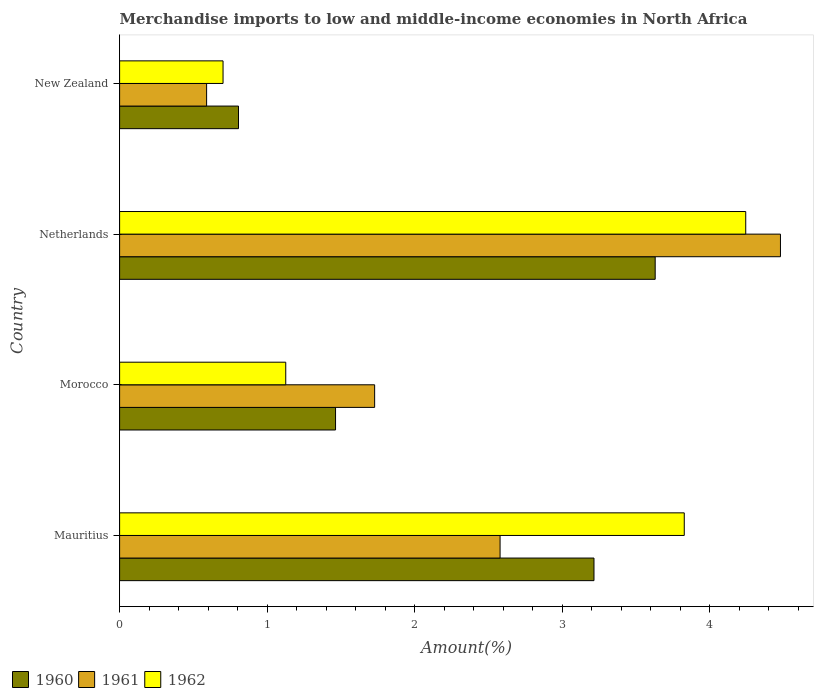How many different coloured bars are there?
Your answer should be compact. 3. How many groups of bars are there?
Ensure brevity in your answer.  4. Are the number of bars per tick equal to the number of legend labels?
Keep it short and to the point. Yes. What is the label of the 3rd group of bars from the top?
Ensure brevity in your answer.  Morocco. In how many cases, is the number of bars for a given country not equal to the number of legend labels?
Ensure brevity in your answer.  0. What is the percentage of amount earned from merchandise imports in 1960 in Netherlands?
Provide a short and direct response. 3.63. Across all countries, what is the maximum percentage of amount earned from merchandise imports in 1961?
Keep it short and to the point. 4.48. Across all countries, what is the minimum percentage of amount earned from merchandise imports in 1961?
Your response must be concise. 0.59. In which country was the percentage of amount earned from merchandise imports in 1961 maximum?
Your answer should be compact. Netherlands. In which country was the percentage of amount earned from merchandise imports in 1961 minimum?
Make the answer very short. New Zealand. What is the total percentage of amount earned from merchandise imports in 1962 in the graph?
Provide a short and direct response. 9.9. What is the difference between the percentage of amount earned from merchandise imports in 1960 in Mauritius and that in Netherlands?
Make the answer very short. -0.42. What is the difference between the percentage of amount earned from merchandise imports in 1961 in Netherlands and the percentage of amount earned from merchandise imports in 1960 in Mauritius?
Offer a very short reply. 1.26. What is the average percentage of amount earned from merchandise imports in 1961 per country?
Offer a terse response. 2.34. What is the difference between the percentage of amount earned from merchandise imports in 1962 and percentage of amount earned from merchandise imports in 1960 in Netherlands?
Give a very brief answer. 0.61. In how many countries, is the percentage of amount earned from merchandise imports in 1961 greater than 1 %?
Your response must be concise. 3. What is the ratio of the percentage of amount earned from merchandise imports in 1960 in Mauritius to that in Netherlands?
Offer a terse response. 0.89. What is the difference between the highest and the second highest percentage of amount earned from merchandise imports in 1962?
Provide a short and direct response. 0.42. What is the difference between the highest and the lowest percentage of amount earned from merchandise imports in 1961?
Make the answer very short. 3.89. What does the 1st bar from the bottom in New Zealand represents?
Offer a very short reply. 1960. Is it the case that in every country, the sum of the percentage of amount earned from merchandise imports in 1961 and percentage of amount earned from merchandise imports in 1960 is greater than the percentage of amount earned from merchandise imports in 1962?
Your response must be concise. Yes. Are all the bars in the graph horizontal?
Offer a terse response. Yes. What is the difference between two consecutive major ticks on the X-axis?
Make the answer very short. 1. Are the values on the major ticks of X-axis written in scientific E-notation?
Offer a terse response. No. Where does the legend appear in the graph?
Your response must be concise. Bottom left. What is the title of the graph?
Keep it short and to the point. Merchandise imports to low and middle-income economies in North Africa. Does "1989" appear as one of the legend labels in the graph?
Offer a terse response. No. What is the label or title of the X-axis?
Give a very brief answer. Amount(%). What is the label or title of the Y-axis?
Your answer should be very brief. Country. What is the Amount(%) in 1960 in Mauritius?
Provide a short and direct response. 3.22. What is the Amount(%) of 1961 in Mauritius?
Keep it short and to the point. 2.58. What is the Amount(%) of 1962 in Mauritius?
Your answer should be compact. 3.83. What is the Amount(%) of 1960 in Morocco?
Ensure brevity in your answer.  1.46. What is the Amount(%) of 1961 in Morocco?
Provide a succinct answer. 1.73. What is the Amount(%) of 1962 in Morocco?
Your answer should be compact. 1.13. What is the Amount(%) of 1960 in Netherlands?
Your answer should be compact. 3.63. What is the Amount(%) in 1961 in Netherlands?
Keep it short and to the point. 4.48. What is the Amount(%) of 1962 in Netherlands?
Your answer should be very brief. 4.25. What is the Amount(%) in 1960 in New Zealand?
Offer a terse response. 0.81. What is the Amount(%) in 1961 in New Zealand?
Offer a very short reply. 0.59. What is the Amount(%) in 1962 in New Zealand?
Your response must be concise. 0.7. Across all countries, what is the maximum Amount(%) of 1960?
Give a very brief answer. 3.63. Across all countries, what is the maximum Amount(%) of 1961?
Your answer should be compact. 4.48. Across all countries, what is the maximum Amount(%) of 1962?
Ensure brevity in your answer.  4.25. Across all countries, what is the minimum Amount(%) in 1960?
Keep it short and to the point. 0.81. Across all countries, what is the minimum Amount(%) in 1961?
Your response must be concise. 0.59. Across all countries, what is the minimum Amount(%) in 1962?
Keep it short and to the point. 0.7. What is the total Amount(%) in 1960 in the graph?
Offer a very short reply. 9.12. What is the total Amount(%) of 1961 in the graph?
Make the answer very short. 9.38. What is the total Amount(%) in 1962 in the graph?
Offer a very short reply. 9.9. What is the difference between the Amount(%) in 1960 in Mauritius and that in Morocco?
Give a very brief answer. 1.75. What is the difference between the Amount(%) in 1961 in Mauritius and that in Morocco?
Provide a succinct answer. 0.85. What is the difference between the Amount(%) of 1962 in Mauritius and that in Morocco?
Your answer should be compact. 2.7. What is the difference between the Amount(%) in 1960 in Mauritius and that in Netherlands?
Offer a very short reply. -0.41. What is the difference between the Amount(%) in 1961 in Mauritius and that in Netherlands?
Keep it short and to the point. -1.9. What is the difference between the Amount(%) of 1962 in Mauritius and that in Netherlands?
Give a very brief answer. -0.42. What is the difference between the Amount(%) of 1960 in Mauritius and that in New Zealand?
Your answer should be very brief. 2.41. What is the difference between the Amount(%) in 1961 in Mauritius and that in New Zealand?
Make the answer very short. 1.99. What is the difference between the Amount(%) of 1962 in Mauritius and that in New Zealand?
Offer a very short reply. 3.13. What is the difference between the Amount(%) in 1960 in Morocco and that in Netherlands?
Offer a very short reply. -2.17. What is the difference between the Amount(%) of 1961 in Morocco and that in Netherlands?
Offer a very short reply. -2.75. What is the difference between the Amount(%) in 1962 in Morocco and that in Netherlands?
Provide a short and direct response. -3.12. What is the difference between the Amount(%) in 1960 in Morocco and that in New Zealand?
Your response must be concise. 0.66. What is the difference between the Amount(%) of 1961 in Morocco and that in New Zealand?
Offer a very short reply. 1.14. What is the difference between the Amount(%) in 1962 in Morocco and that in New Zealand?
Provide a short and direct response. 0.43. What is the difference between the Amount(%) in 1960 in Netherlands and that in New Zealand?
Make the answer very short. 2.83. What is the difference between the Amount(%) of 1961 in Netherlands and that in New Zealand?
Make the answer very short. 3.89. What is the difference between the Amount(%) of 1962 in Netherlands and that in New Zealand?
Your answer should be compact. 3.54. What is the difference between the Amount(%) of 1960 in Mauritius and the Amount(%) of 1961 in Morocco?
Offer a very short reply. 1.49. What is the difference between the Amount(%) of 1960 in Mauritius and the Amount(%) of 1962 in Morocco?
Give a very brief answer. 2.09. What is the difference between the Amount(%) of 1961 in Mauritius and the Amount(%) of 1962 in Morocco?
Keep it short and to the point. 1.45. What is the difference between the Amount(%) in 1960 in Mauritius and the Amount(%) in 1961 in Netherlands?
Provide a short and direct response. -1.26. What is the difference between the Amount(%) of 1960 in Mauritius and the Amount(%) of 1962 in Netherlands?
Make the answer very short. -1.03. What is the difference between the Amount(%) of 1961 in Mauritius and the Amount(%) of 1962 in Netherlands?
Keep it short and to the point. -1.67. What is the difference between the Amount(%) of 1960 in Mauritius and the Amount(%) of 1961 in New Zealand?
Provide a short and direct response. 2.63. What is the difference between the Amount(%) in 1960 in Mauritius and the Amount(%) in 1962 in New Zealand?
Make the answer very short. 2.52. What is the difference between the Amount(%) in 1961 in Mauritius and the Amount(%) in 1962 in New Zealand?
Make the answer very short. 1.88. What is the difference between the Amount(%) of 1960 in Morocco and the Amount(%) of 1961 in Netherlands?
Keep it short and to the point. -3.02. What is the difference between the Amount(%) in 1960 in Morocco and the Amount(%) in 1962 in Netherlands?
Your answer should be compact. -2.78. What is the difference between the Amount(%) of 1961 in Morocco and the Amount(%) of 1962 in Netherlands?
Ensure brevity in your answer.  -2.52. What is the difference between the Amount(%) of 1960 in Morocco and the Amount(%) of 1961 in New Zealand?
Your answer should be very brief. 0.87. What is the difference between the Amount(%) in 1960 in Morocco and the Amount(%) in 1962 in New Zealand?
Offer a terse response. 0.76. What is the difference between the Amount(%) of 1961 in Morocco and the Amount(%) of 1962 in New Zealand?
Your answer should be very brief. 1.03. What is the difference between the Amount(%) in 1960 in Netherlands and the Amount(%) in 1961 in New Zealand?
Provide a short and direct response. 3.04. What is the difference between the Amount(%) in 1960 in Netherlands and the Amount(%) in 1962 in New Zealand?
Provide a succinct answer. 2.93. What is the difference between the Amount(%) in 1961 in Netherlands and the Amount(%) in 1962 in New Zealand?
Ensure brevity in your answer.  3.78. What is the average Amount(%) of 1960 per country?
Your answer should be compact. 2.28. What is the average Amount(%) of 1961 per country?
Your answer should be very brief. 2.34. What is the average Amount(%) in 1962 per country?
Provide a short and direct response. 2.48. What is the difference between the Amount(%) in 1960 and Amount(%) in 1961 in Mauritius?
Keep it short and to the point. 0.64. What is the difference between the Amount(%) of 1960 and Amount(%) of 1962 in Mauritius?
Give a very brief answer. -0.61. What is the difference between the Amount(%) of 1961 and Amount(%) of 1962 in Mauritius?
Provide a succinct answer. -1.25. What is the difference between the Amount(%) in 1960 and Amount(%) in 1961 in Morocco?
Provide a short and direct response. -0.27. What is the difference between the Amount(%) of 1960 and Amount(%) of 1962 in Morocco?
Give a very brief answer. 0.34. What is the difference between the Amount(%) of 1961 and Amount(%) of 1962 in Morocco?
Provide a short and direct response. 0.6. What is the difference between the Amount(%) of 1960 and Amount(%) of 1961 in Netherlands?
Your response must be concise. -0.85. What is the difference between the Amount(%) in 1960 and Amount(%) in 1962 in Netherlands?
Ensure brevity in your answer.  -0.61. What is the difference between the Amount(%) in 1961 and Amount(%) in 1962 in Netherlands?
Provide a succinct answer. 0.24. What is the difference between the Amount(%) in 1960 and Amount(%) in 1961 in New Zealand?
Your answer should be very brief. 0.22. What is the difference between the Amount(%) of 1960 and Amount(%) of 1962 in New Zealand?
Your response must be concise. 0.1. What is the difference between the Amount(%) in 1961 and Amount(%) in 1962 in New Zealand?
Provide a succinct answer. -0.11. What is the ratio of the Amount(%) in 1960 in Mauritius to that in Morocco?
Provide a short and direct response. 2.2. What is the ratio of the Amount(%) in 1961 in Mauritius to that in Morocco?
Provide a succinct answer. 1.49. What is the ratio of the Amount(%) in 1962 in Mauritius to that in Morocco?
Make the answer very short. 3.4. What is the ratio of the Amount(%) of 1960 in Mauritius to that in Netherlands?
Ensure brevity in your answer.  0.89. What is the ratio of the Amount(%) in 1961 in Mauritius to that in Netherlands?
Provide a succinct answer. 0.58. What is the ratio of the Amount(%) in 1962 in Mauritius to that in Netherlands?
Offer a very short reply. 0.9. What is the ratio of the Amount(%) in 1960 in Mauritius to that in New Zealand?
Ensure brevity in your answer.  3.99. What is the ratio of the Amount(%) of 1961 in Mauritius to that in New Zealand?
Give a very brief answer. 4.37. What is the ratio of the Amount(%) in 1962 in Mauritius to that in New Zealand?
Offer a terse response. 5.46. What is the ratio of the Amount(%) of 1960 in Morocco to that in Netherlands?
Make the answer very short. 0.4. What is the ratio of the Amount(%) of 1961 in Morocco to that in Netherlands?
Offer a very short reply. 0.39. What is the ratio of the Amount(%) in 1962 in Morocco to that in Netherlands?
Provide a short and direct response. 0.27. What is the ratio of the Amount(%) of 1960 in Morocco to that in New Zealand?
Offer a very short reply. 1.82. What is the ratio of the Amount(%) in 1961 in Morocco to that in New Zealand?
Ensure brevity in your answer.  2.93. What is the ratio of the Amount(%) in 1962 in Morocco to that in New Zealand?
Your response must be concise. 1.61. What is the ratio of the Amount(%) of 1960 in Netherlands to that in New Zealand?
Your response must be concise. 4.5. What is the ratio of the Amount(%) of 1961 in Netherlands to that in New Zealand?
Provide a short and direct response. 7.6. What is the ratio of the Amount(%) in 1962 in Netherlands to that in New Zealand?
Your answer should be very brief. 6.05. What is the difference between the highest and the second highest Amount(%) of 1960?
Offer a terse response. 0.41. What is the difference between the highest and the second highest Amount(%) in 1961?
Provide a short and direct response. 1.9. What is the difference between the highest and the second highest Amount(%) in 1962?
Ensure brevity in your answer.  0.42. What is the difference between the highest and the lowest Amount(%) of 1960?
Offer a terse response. 2.83. What is the difference between the highest and the lowest Amount(%) of 1961?
Your answer should be very brief. 3.89. What is the difference between the highest and the lowest Amount(%) of 1962?
Offer a very short reply. 3.54. 